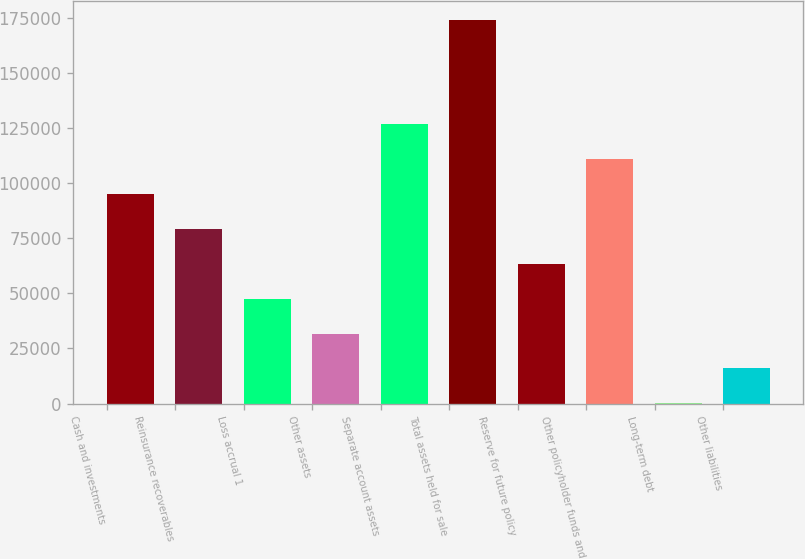Convert chart. <chart><loc_0><loc_0><loc_500><loc_500><bar_chart><fcel>Cash and investments<fcel>Reinsurance recoverables<fcel>Loss accrual 1<fcel>Other assets<fcel>Separate account assets<fcel>Total assets held for sale<fcel>Reserve for future policy<fcel>Other policyholder funds and<fcel>Long-term debt<fcel>Other liabilities<nl><fcel>95104<fcel>79277<fcel>47623<fcel>31796<fcel>126758<fcel>174239<fcel>63450<fcel>110931<fcel>142<fcel>15969<nl></chart> 